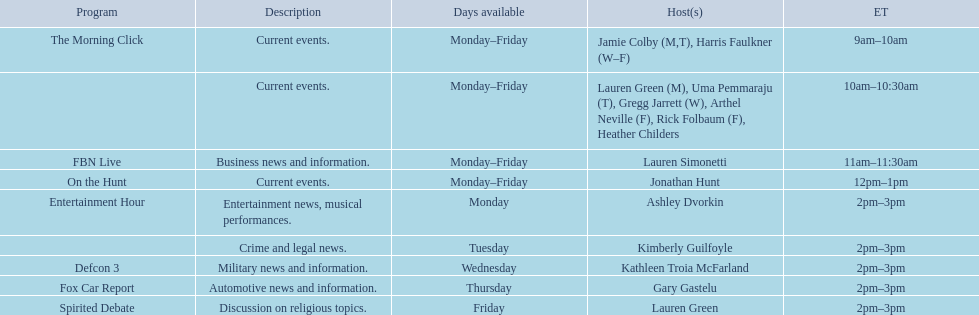Tell me the number of shows that only have one host per day. 7. 